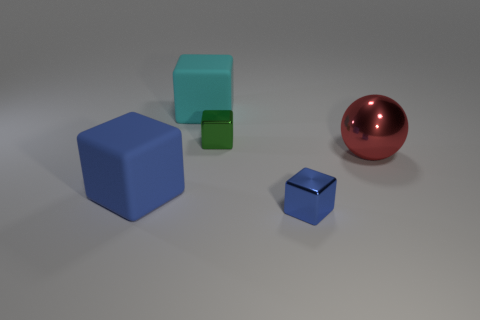What is the cube that is both in front of the shiny sphere and behind the tiny blue shiny cube made of?
Provide a succinct answer. Rubber. There is another block that is made of the same material as the cyan cube; what is its color?
Provide a short and direct response. Blue. Does the tiny green shiny object have the same shape as the large cyan rubber object?
Your answer should be compact. Yes. What is the size of the rubber block that is in front of the large cube behind the small cube behind the blue matte object?
Ensure brevity in your answer.  Large. Is the color of the small object that is in front of the ball the same as the large rubber block in front of the big cyan cube?
Offer a very short reply. Yes. How many gray things are either metal things or balls?
Your response must be concise. 0. How many blocks have the same size as the red metal ball?
Your answer should be compact. 2. Do the large blue cube on the left side of the green metallic thing and the large cyan thing have the same material?
Offer a terse response. Yes. There is a red metallic sphere in front of the green cube; is there a small block behind it?
Your answer should be compact. Yes. There is a large cyan object that is the same shape as the green object; what is it made of?
Make the answer very short. Rubber. 